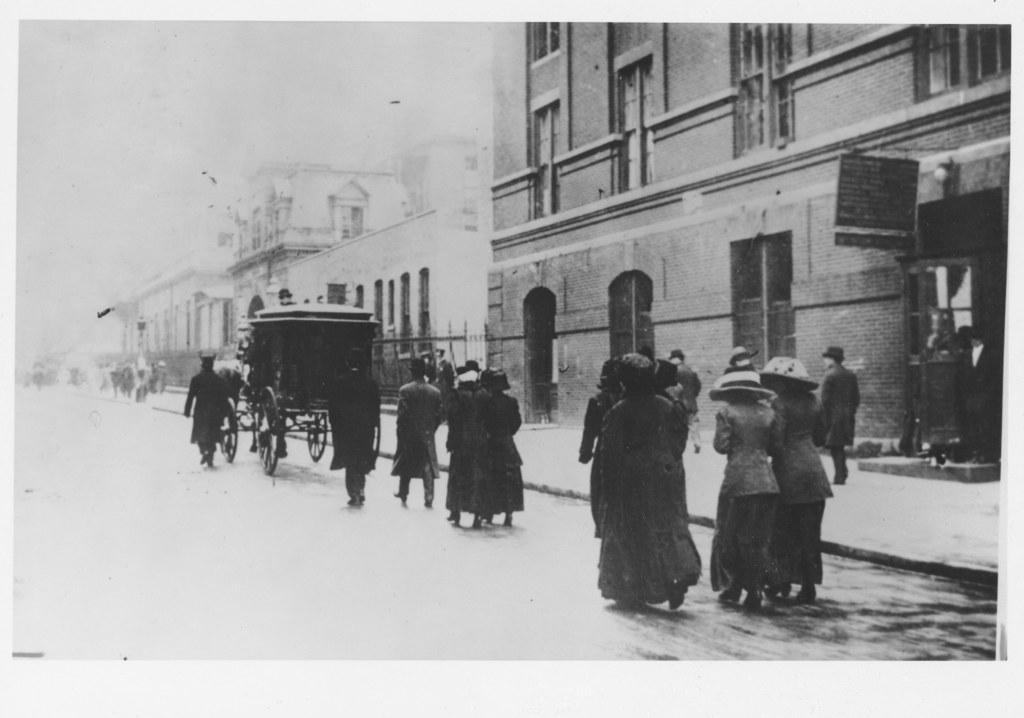What is the main object in the image? There is a cart in the image. Who or what is present near the cart? There is a group of people in the image. What type of structures can be seen in the image? There are buildings in the image. What feature of the buildings is visible in the image? There are windows in the image. What is visible at the top of the image? The sky is visible at the top of the image. How many sheep are grazing in the yard in the image? There are no sheep or yards present in the image. 